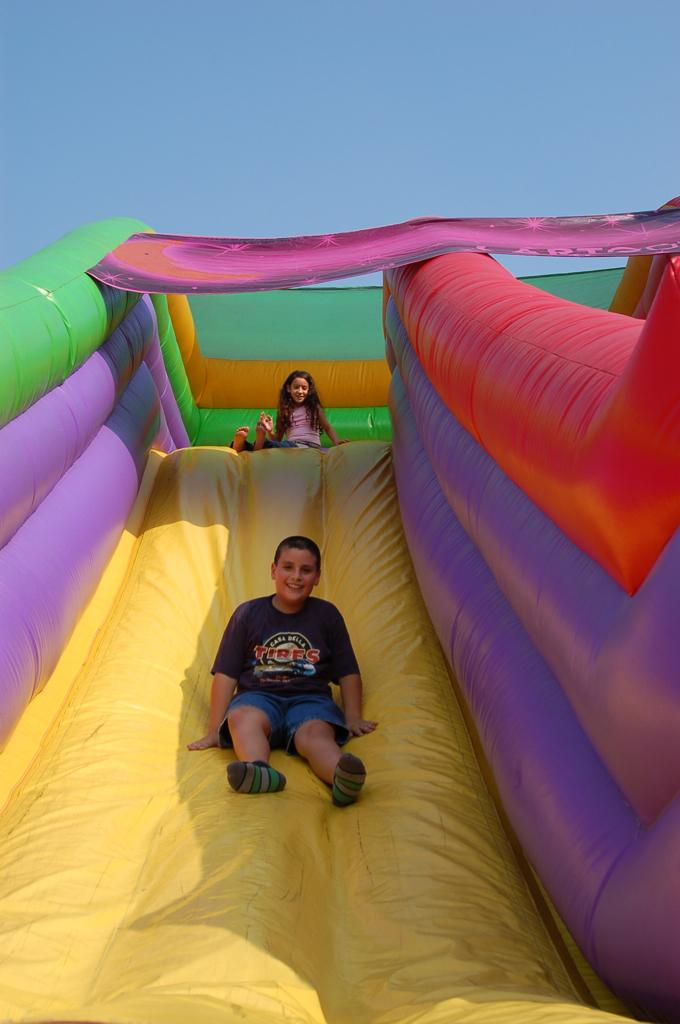How many kids are in the image? There are two kids in the image. What are the kids doing in the image? The kids are on a garden slide. What are the kids wearing in the image? The kids are wearing clothes. What is visible at the top of the image? There is a sky visible at the top of the image. What type of sound can be heard coming from the birds in the image? There are no birds present in the image, so it is not possible to determine what, let alone hear any sounds they might make. 